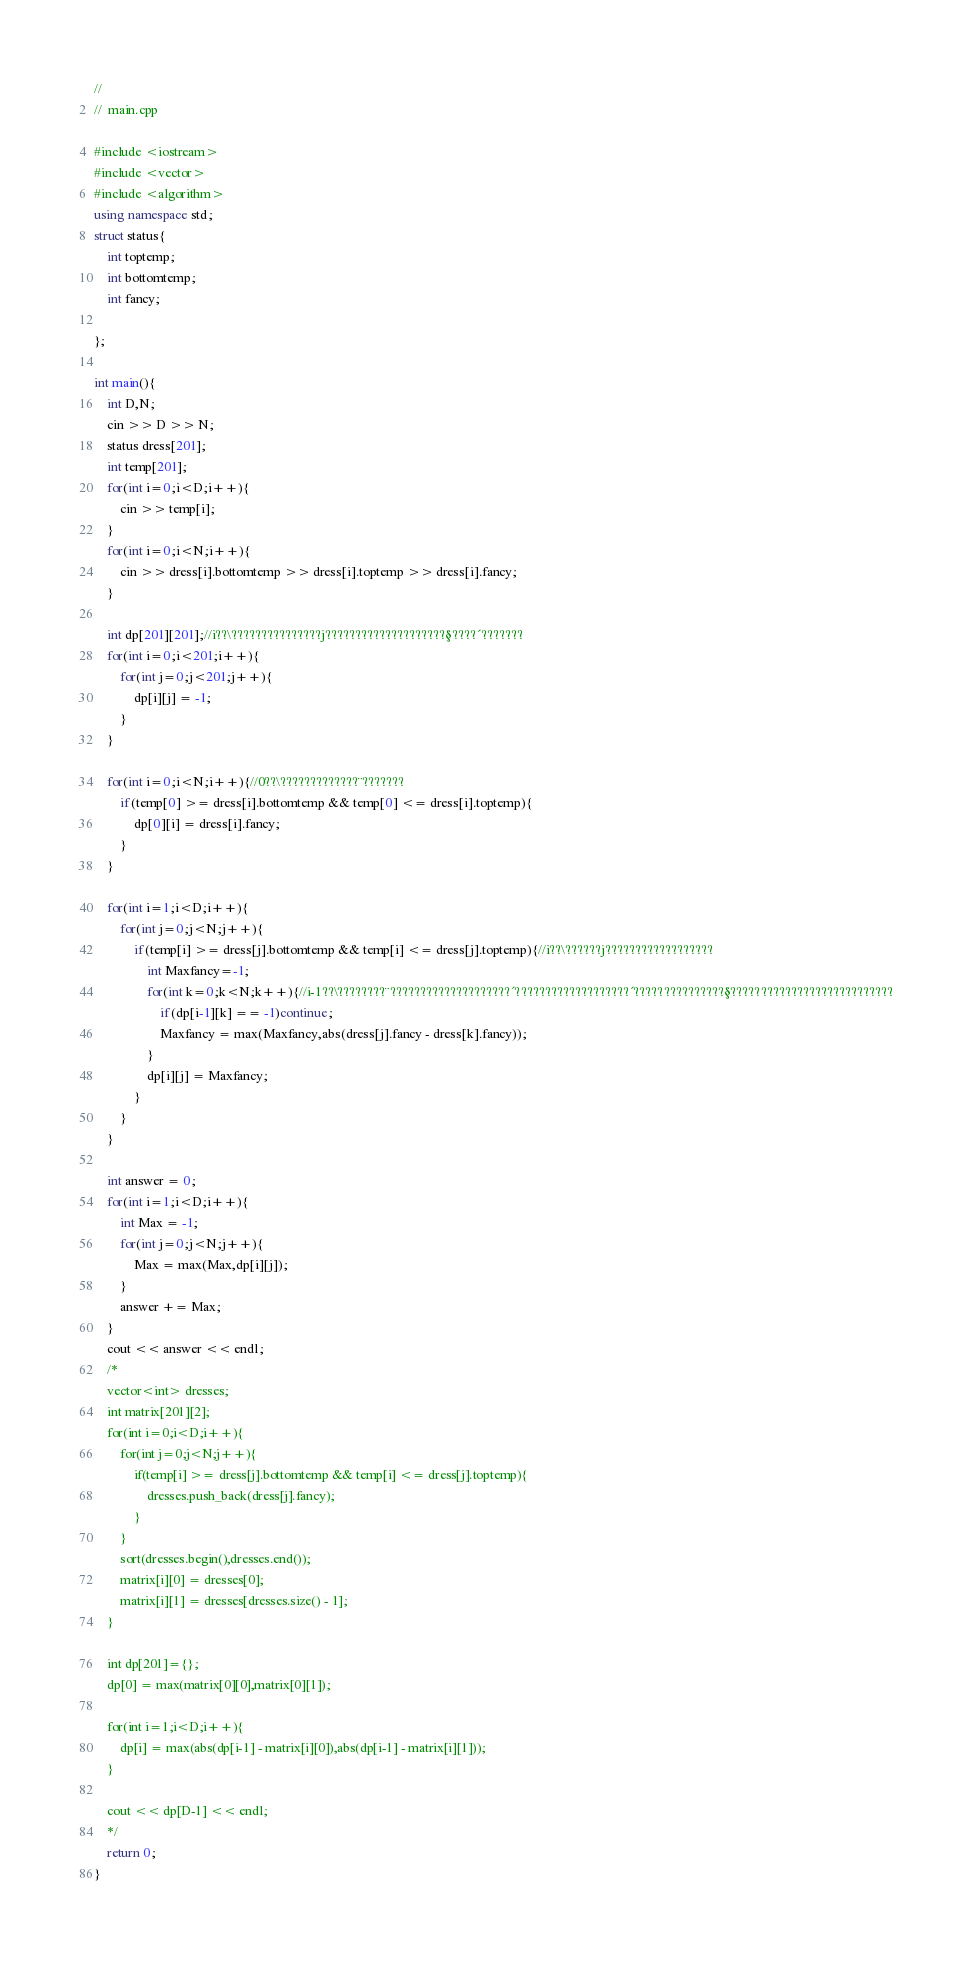<code> <loc_0><loc_0><loc_500><loc_500><_C++_>//
//  main.cpp

#include <iostream>
#include <vector>
#include <algorithm>
using namespace std;
struct status{
	int toptemp;
	int bottomtemp;
	int fancy;
	
};

int main(){	
	int D,N;
	cin >> D >> N;
	status dress[201];
	int temp[201];
	for(int i=0;i<D;i++){
		cin >> temp[i];
	}
	for(int i=0;i<N;i++){
		cin >> dress[i].bottomtemp >> dress[i].toptemp >> dress[i].fancy;
	}
	
	int dp[201][201];//i??\???????????????j????????????????????§????´???????
	for(int i=0;i<201;i++){
		for(int j=0;j<201;j++){
			dp[i][j] = -1;
		}
	}
	
	for(int i=0;i<N;i++){//0??\?????????????¨???????
		if(temp[0] >= dress[i].bottomtemp && temp[0] <= dress[i].toptemp){
			dp[0][i] = dress[i].fancy;
		}
	}
	
	for(int i=1;i<D;i++){
		for(int j=0;j<N;j++){
			if(temp[i] >= dress[j].bottomtemp && temp[i] <= dress[j].toptemp){//i??\??????j??????????????????
				int Maxfancy=-1;
				for(int k=0;k<N;k++){//i-1??\????????¨????????????????????´???????????????????´???????????????§???????????????????????????
					if(dp[i-1][k] == -1)continue;
					Maxfancy = max(Maxfancy,abs(dress[j].fancy - dress[k].fancy));
				}
				dp[i][j] = Maxfancy;
			}
		}
	}
	
	int answer = 0;
	for(int i=1;i<D;i++){
		int Max = -1;
		for(int j=0;j<N;j++){
			Max = max(Max,dp[i][j]);
		}
		answer += Max;
	}
	cout << answer << endl;
	/*
	vector<int> dresses;
	int matrix[201][2];
	for(int i=0;i<D;i++){
		for(int j=0;j<N;j++){
			if(temp[i] >= dress[j].bottomtemp && temp[i] <= dress[j].toptemp){
				dresses.push_back(dress[j].fancy);
			}
		}
		sort(dresses.begin(),dresses.end());
		matrix[i][0] = dresses[0];
		matrix[i][1] = dresses[dresses.size() - 1];
	}
	
	int dp[201]={};
	dp[0] = max(matrix[0][0],matrix[0][1]);
	
	for(int i=1;i<D;i++){
		dp[i] = max(abs(dp[i-1] - matrix[i][0]),abs(dp[i-1] - matrix[i][1]));
	}
	
	cout << dp[D-1] << endl;
	*/
	return 0;
}</code> 